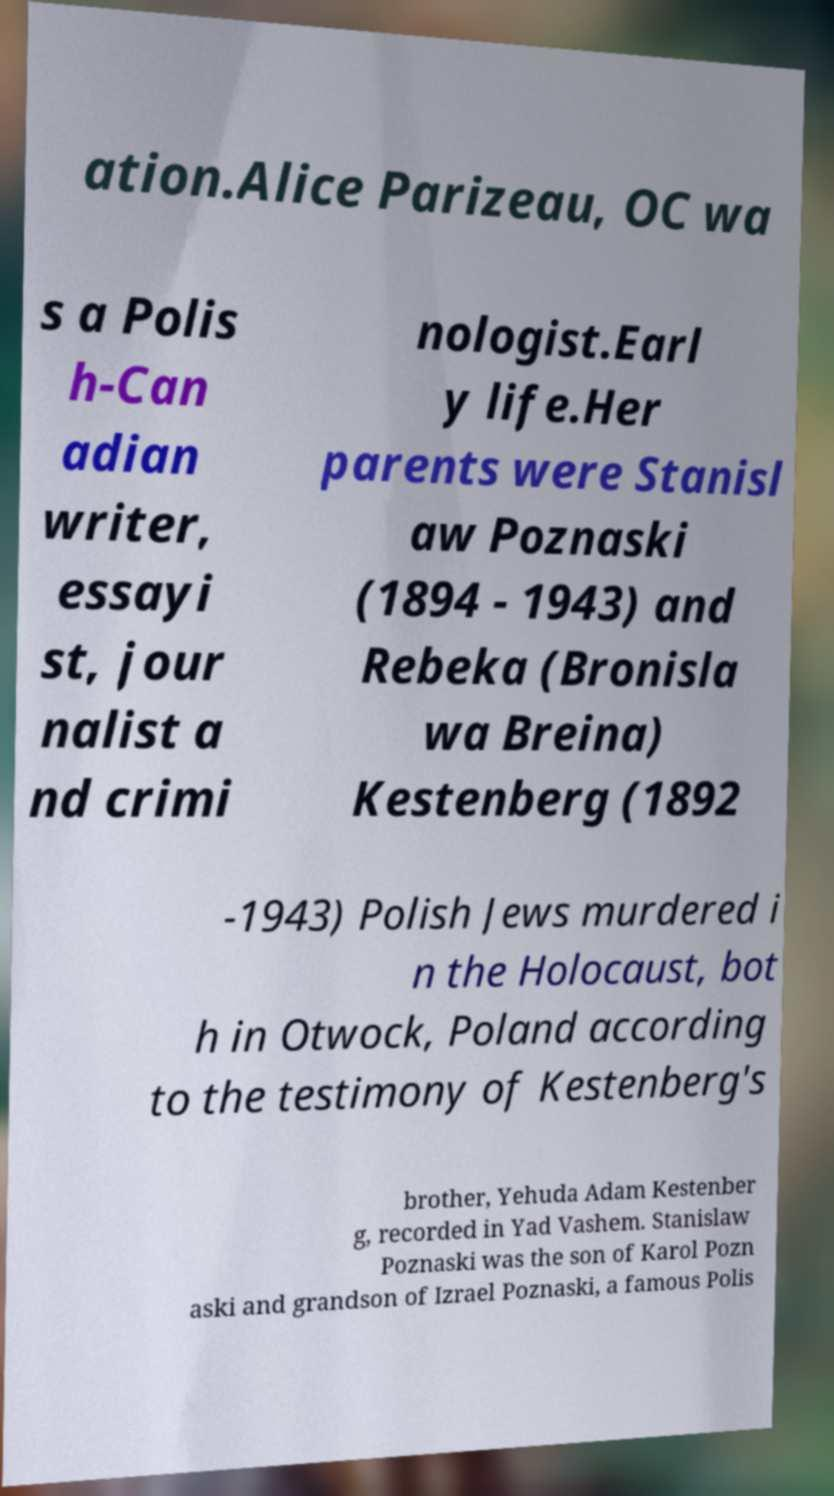For documentation purposes, I need the text within this image transcribed. Could you provide that? ation.Alice Parizeau, OC wa s a Polis h-Can adian writer, essayi st, jour nalist a nd crimi nologist.Earl y life.Her parents were Stanisl aw Poznaski (1894 - 1943) and Rebeka (Bronisla wa Breina) Kestenberg (1892 -1943) Polish Jews murdered i n the Holocaust, bot h in Otwock, Poland according to the testimony of Kestenberg's brother, Yehuda Adam Kestenber g, recorded in Yad Vashem. Stanislaw Poznaski was the son of Karol Pozn aski and grandson of Izrael Poznaski, a famous Polis 